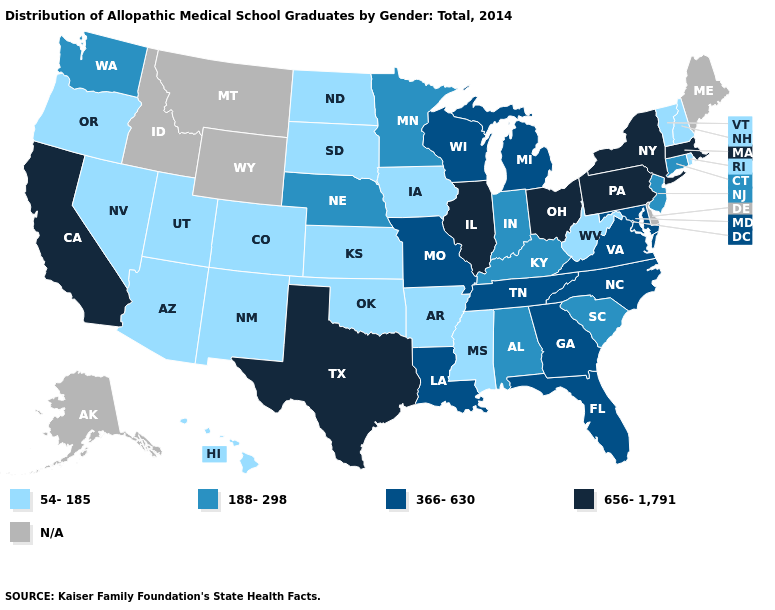Name the states that have a value in the range 366-630?
Short answer required. Florida, Georgia, Louisiana, Maryland, Michigan, Missouri, North Carolina, Tennessee, Virginia, Wisconsin. Name the states that have a value in the range 188-298?
Give a very brief answer. Alabama, Connecticut, Indiana, Kentucky, Minnesota, Nebraska, New Jersey, South Carolina, Washington. What is the lowest value in the USA?
Keep it brief. 54-185. Name the states that have a value in the range 656-1,791?
Give a very brief answer. California, Illinois, Massachusetts, New York, Ohio, Pennsylvania, Texas. Does Mississippi have the lowest value in the South?
Be succinct. Yes. What is the value of Montana?
Quick response, please. N/A. Name the states that have a value in the range 54-185?
Answer briefly. Arizona, Arkansas, Colorado, Hawaii, Iowa, Kansas, Mississippi, Nevada, New Hampshire, New Mexico, North Dakota, Oklahoma, Oregon, Rhode Island, South Dakota, Utah, Vermont, West Virginia. Name the states that have a value in the range 188-298?
Keep it brief. Alabama, Connecticut, Indiana, Kentucky, Minnesota, Nebraska, New Jersey, South Carolina, Washington. Among the states that border Illinois , which have the highest value?
Keep it brief. Missouri, Wisconsin. Which states have the lowest value in the West?
Write a very short answer. Arizona, Colorado, Hawaii, Nevada, New Mexico, Oregon, Utah. Which states hav the highest value in the West?
Quick response, please. California. What is the highest value in the USA?
Give a very brief answer. 656-1,791. Among the states that border West Virginia , which have the highest value?
Quick response, please. Ohio, Pennsylvania. 